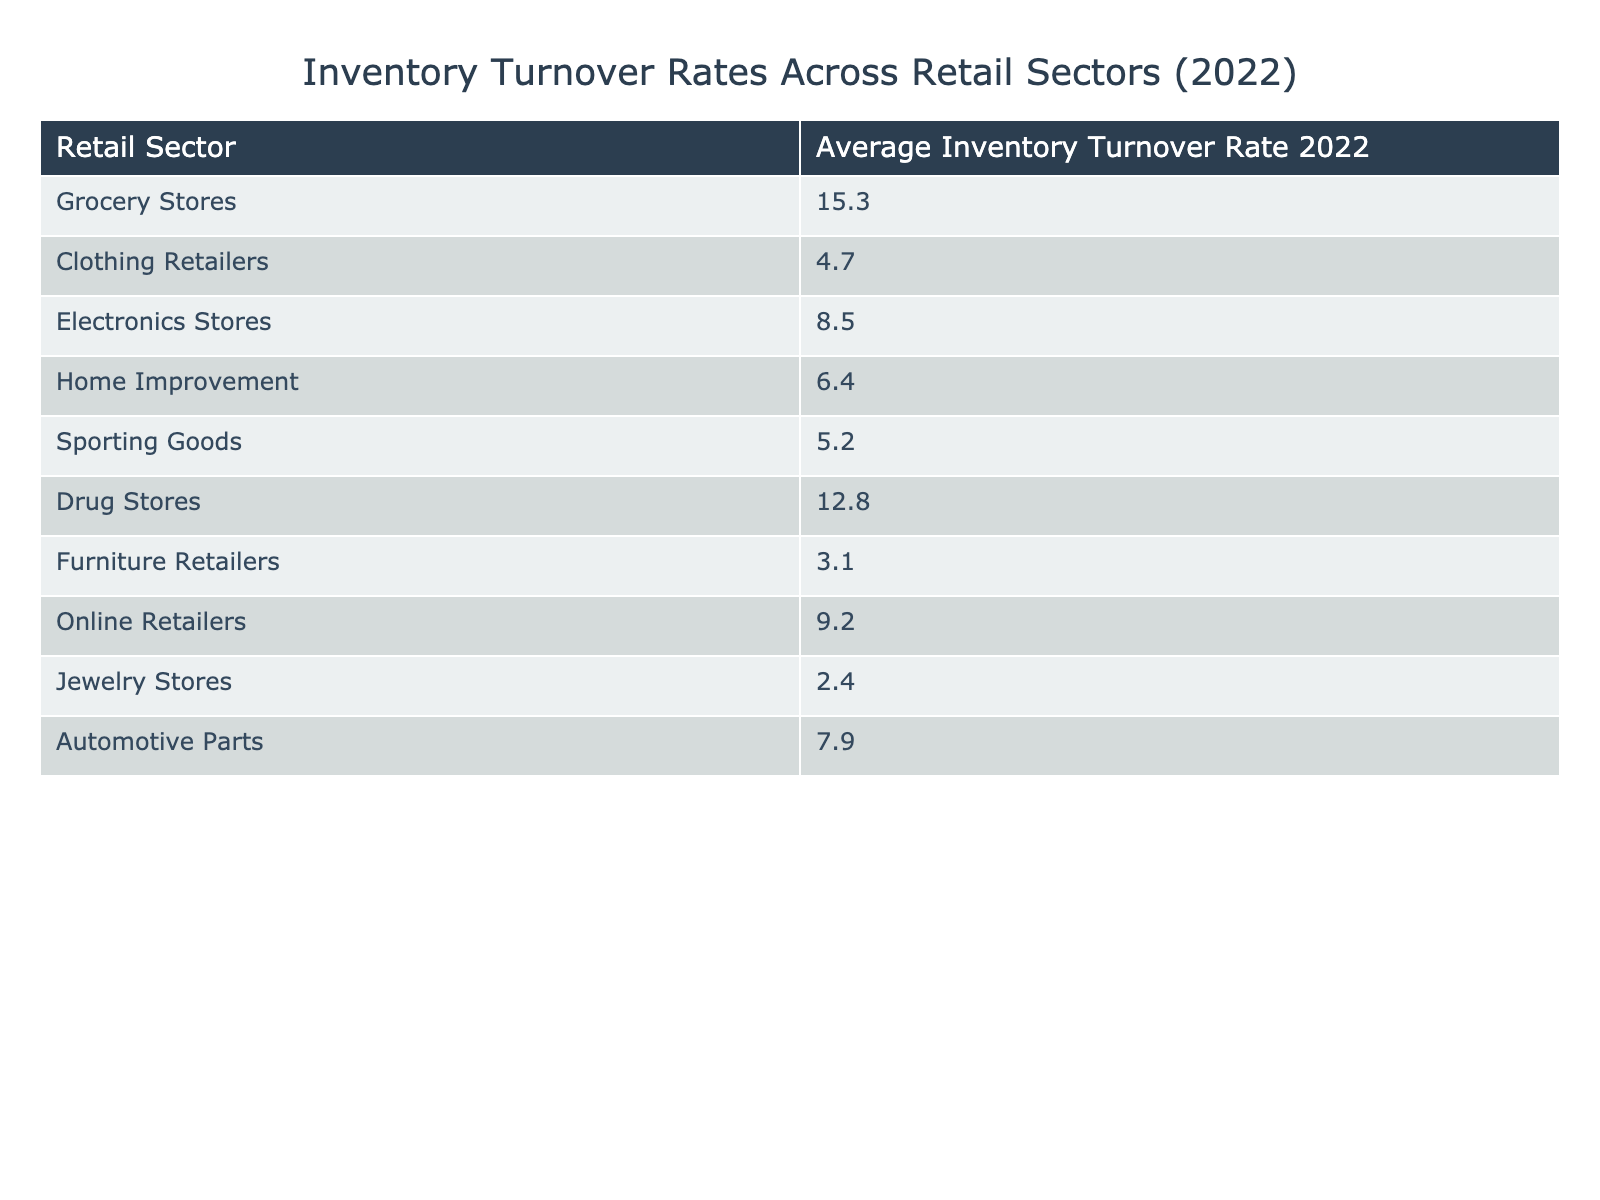What is the inventory turnover rate for grocery stores? The table provides the inventory turnover rate directly next to the grocery store category. It states that the average inventory turnover rate for grocery stores in 2022 is 15.3.
Answer: 15.3 Which retail sector has the lowest inventory turnover rate? By examining the table, we can see that jewelry stores have the lowest inventory turnover rate listed as 2.4.
Answer: Jewelry Stores What is the average inventory turnover rate for clothing retailers and furniture retailers combined? We add the inventory turnover rates for clothing retailers (4.7) and furniture retailers (3.1): 4.7 + 3.1 = 7.8. To find the average of these two sectors, we divide by 2: 7.8 / 2 = 3.9.
Answer: 3.9 Is the inventory turnover rate for electronics stores greater than that for sporting goods stores? The table shows that the inventory turnover rate for electronics stores is 8.5 and for sporting goods stores it is 5.2. Since 8.5 is greater than 5.2, the statement is true.
Answer: Yes Which retail sectors have an inventory turnover rate greater than 10? We look at the table and find that the sectors with turnover rates greater than 10 are grocery stores (15.3) and drug stores (12.8). We can list these sectors accordingly.
Answer: Grocery Stores, Drug Stores What is the total inventory turnover rate for all listed retail sectors? We sum all the individual inventory turnover rates: 15.3 + 4.7 + 8.5 + 6.4 + 5.2 + 12.8 + 3.1 + 9.2 + 2.4 + 7.9 = 75.1. The total rate is 75.1.
Answer: 75.1 How many retail sectors have an inventory turnover rate below 5? We identify the sectors with rates below 5: clothing retailers (4.7), furniture retailers (3.1), and jewelry stores (2.4). This results in a total of three sectors falling below this threshold.
Answer: 3 Is it true that online retailers have a higher inventory turnover rate than automotive parts? Referring to the table, online retailers have a turnover rate of 9.2 and automotive parts have 7.9. Since 9.2 is greater than 7.9, this statement is true.
Answer: Yes 